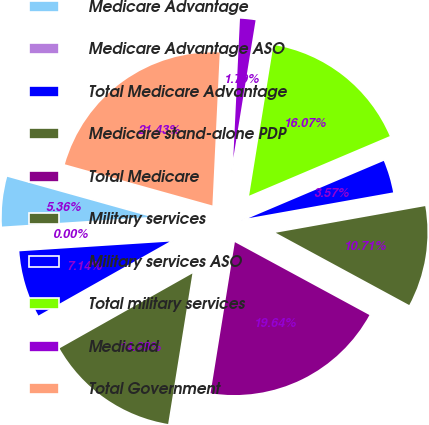Convert chart to OTSL. <chart><loc_0><loc_0><loc_500><loc_500><pie_chart><fcel>Medicare Advantage<fcel>Medicare Advantage ASO<fcel>Total Medicare Advantage<fcel>Medicare stand-alone PDP<fcel>Total Medicare<fcel>Military services<fcel>Military services ASO<fcel>Total military services<fcel>Medicaid<fcel>Total Government<nl><fcel>5.36%<fcel>0.0%<fcel>7.14%<fcel>14.29%<fcel>19.64%<fcel>10.71%<fcel>3.57%<fcel>16.07%<fcel>1.79%<fcel>21.43%<nl></chart> 